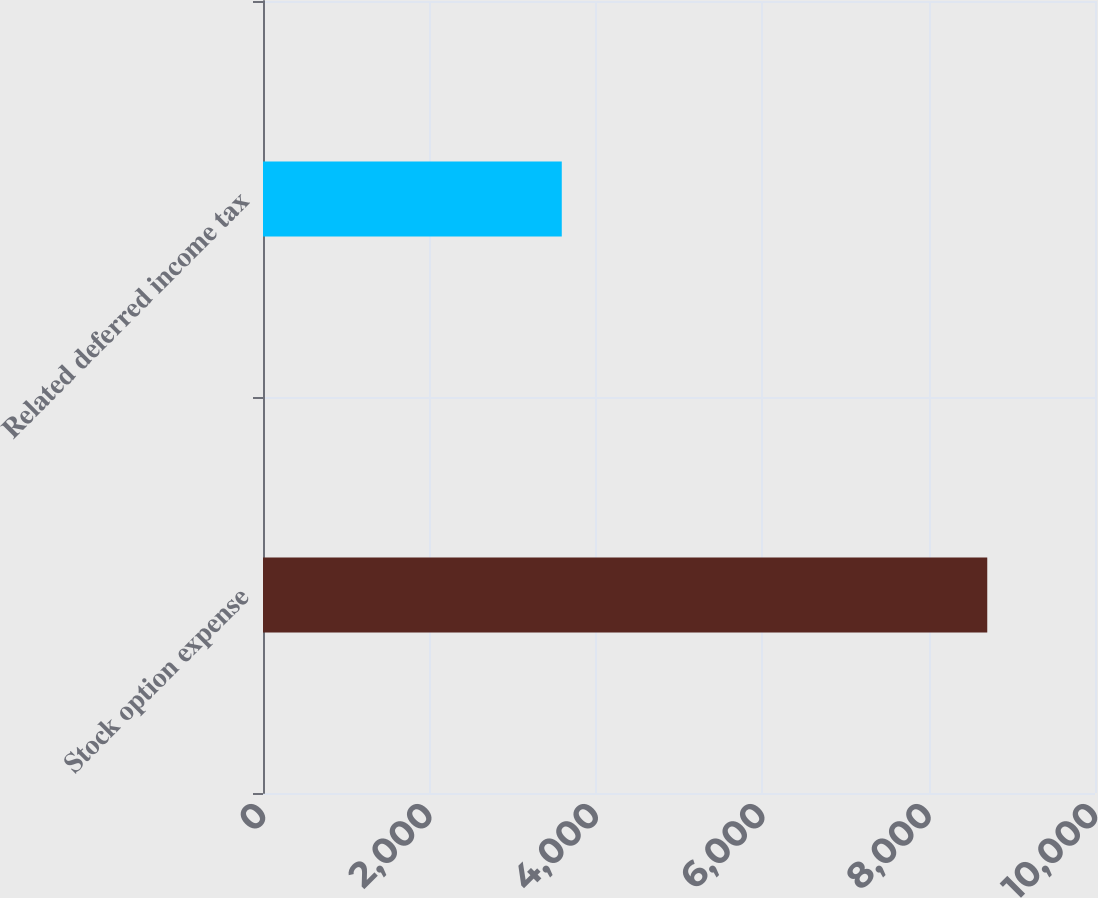Convert chart. <chart><loc_0><loc_0><loc_500><loc_500><bar_chart><fcel>Stock option expense<fcel>Related deferred income tax<nl><fcel>8705<fcel>3591<nl></chart> 